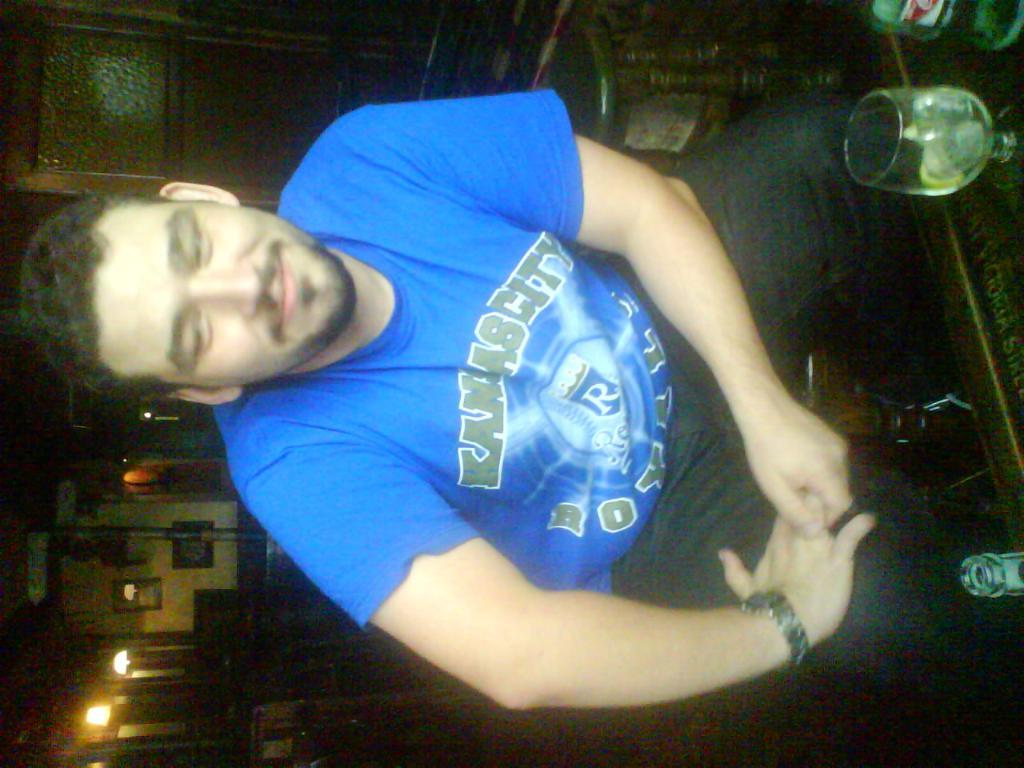What is the man in the image doing? The man is sitting in the image. Where is the man located in relation to the table? The man is in front of a table. What can be seen on the table in the image? There is a glass and a bottle on the table. What is visible in the background of the image? There are photo frames and lights in the background of the image. How many mice are hiding under the table in the image? There are no mice visible in the image, and therefore no mice can be hiding under the table. 